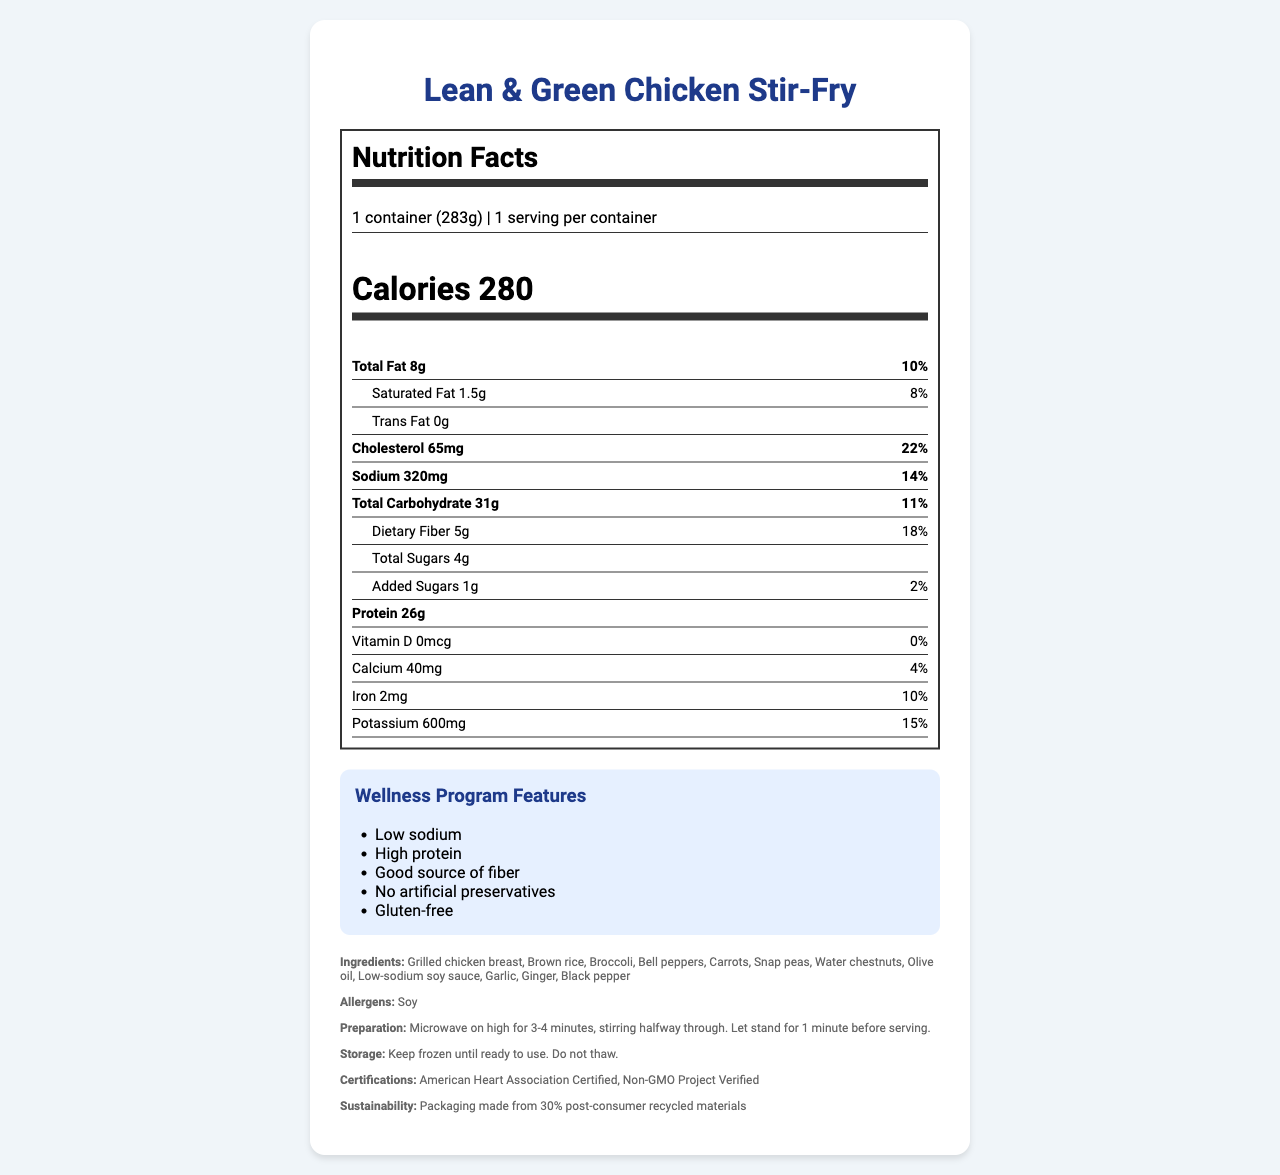what is the serving size? The serving size is specified at the beginning of the nutrition facts section and is listed as "1 container (283g)".
Answer: 1 container (283g) how much sodium does the Lean & Green Chicken Stir-Fry contain? The sodium content is listed under the nutrition facts section and states "Sodium 320mg".
Answer: 320mg what percentage of the daily value of dietary fiber does this meal provide? The daily value percentage of dietary fiber is directly stated in the nutrition facts section as "Dietary Fiber 18%".
Answer: 18% how many grams of protein are in this meal? The protein content is clearly listed in the nutrition facts as "Protein 26g".
Answer: 26g are there any added sugars in this meal? The document states "Added Sugars 1g" under the nutrition facts.
Answer: Yes what certification does this meal have from a health association? The additional info section mentions "American Heart Association Certified" under certifications.
Answer: American Heart Association Certified what type of ingredients does the Lean & Green Chicken Stir-Fry avoid using? A. Artificial preservatives B. Gluten C. Both A and B The wellness program features list "No artificial preservatives" and "Gluten-free".
Answer: C which nutrient has the highest daily value percentage in this meal? A. Sodium B. Protein C. Cholesterol D. Vitamin D The cholesterol percentage is 22%, higher than any other listed nutrient's daily value percentage.
Answer: C. Cholesterol is this meal a significant source of Vitamin D? The document states that Vitamin D has 0% daily value.
Answer: No describe the wellness program features of this meal These features are listed under the wellness program features section.
Answer: This meal is low in sodium, high in protein, a good source of fiber, contains no artificial preservatives, and is gluten-free. is there an allergen present in the meal? Under the allergens section, the document lists Soy.
Answer: Yes, Soy what are the preparation instructions for this meal? The preparation instructions are clearly stated in the additional info section.
Answer: Microwave on high for 3-4 minutes, stirring halfway through. Let stand for 1 minute before serving. how much calcium does this meal provide? The nutrition facts section lists Calcium as "40mg".
Answer: 40mg what percentage of your daily potassium need can this meal fulfill? The nutrition facts list Potassium's daily value as 15%.
Answer: 15% does the document mention the environmental impact of the packaging? The sustainability info section mentions that the packaging is made from 30% post-consumer recycled materials.
Answer: Yes, the packaging is made from 30% post-consumer recycled materials. can you tell if any of the ingredients are organic? The document does not specify whether any of the ingredients are organic.
Answer: Not enough information 